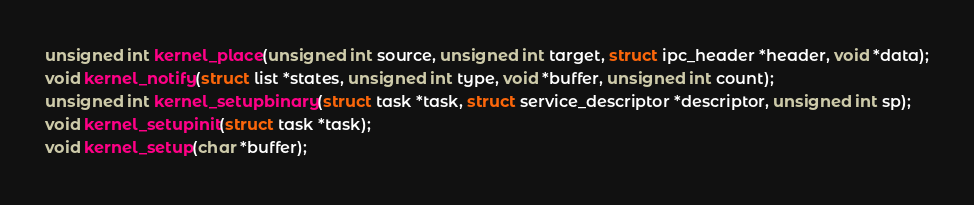Convert code to text. <code><loc_0><loc_0><loc_500><loc_500><_C_>unsigned int kernel_place(unsigned int source, unsigned int target, struct ipc_header *header, void *data);
void kernel_notify(struct list *states, unsigned int type, void *buffer, unsigned int count);
unsigned int kernel_setupbinary(struct task *task, struct service_descriptor *descriptor, unsigned int sp);
void kernel_setupinit(struct task *task);
void kernel_setup(char *buffer);
</code> 